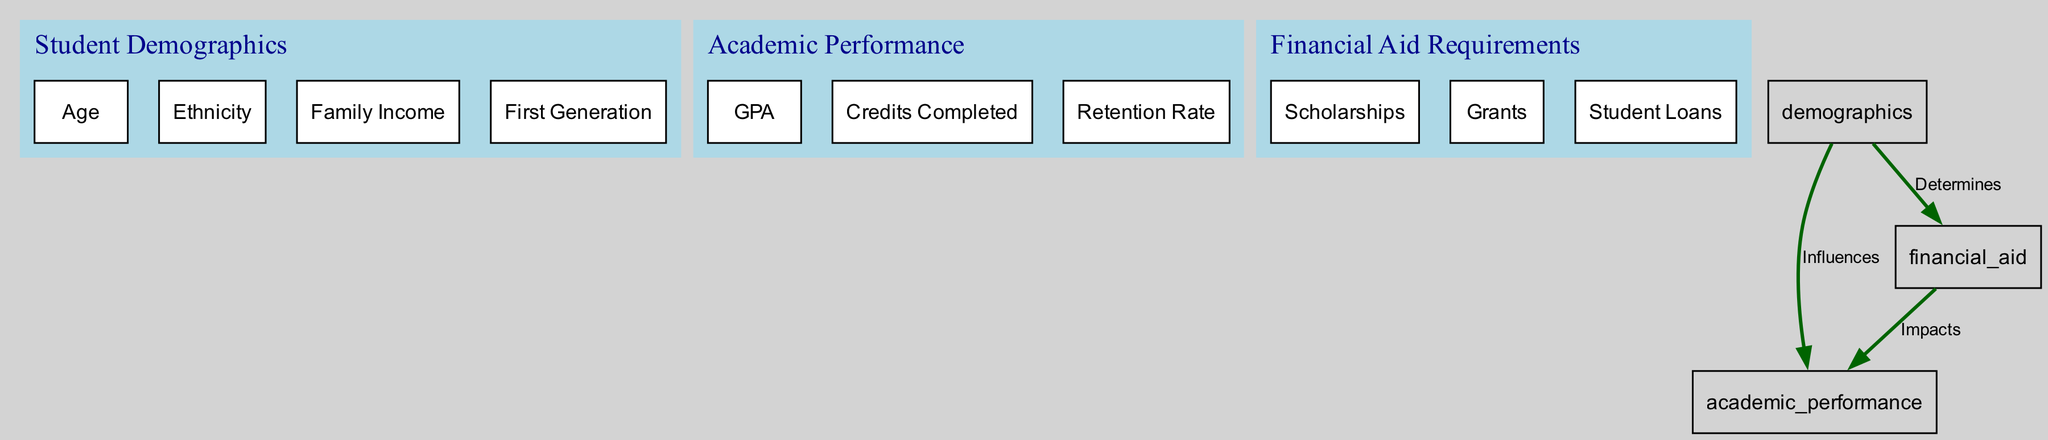What are the three main categories represented in the diagram? The diagram shows three main categories: Student Demographics, Academic Performance, and Financial Aid Requirements, as indicated by the distinct clusters.
Answer: Student Demographics, Academic Performance, Financial Aid Requirements How many children does the Student Demographics node have? The Student Demographics node includes four children: Age, Ethnicity, Family Income, and First Generation, which can be counted in the respective cluster.
Answer: Four What is the relationship between Student Demographics and Academic Performance? The edge between Student Demographics and Academic Performance is labeled "Influences," indicating that demographics have an impact on students' academic performance in the diagram.
Answer: Influences Which financial aid type impacts academic performance? The edge from Financial Aid Requirements to Academic Performance is labeled "Impacts," suggesting that financial aid can affect students' academic performance.
Answer: Impacts What are the elements that determine financial aid requirements? The Financial Aid Requirements node is determined by the Student Demographics, particularly the aspects of family income and first-generation status, as implied by the outgoing edge.
Answer: Family Income, First Generation How many edges are present in the diagram? The diagram features three edges connecting the nodes, specifically describing the relationships between Student Demographics, Academic Performance, and Financial Aid Requirements.
Answer: Three What influence does Family Income have in the diagram? Family Income falls under the influences from Student Demographics to Academic Performance, meaning it impacts academic performance indirectly through demographic variables.
Answer: Influences academic performance What node impacts academic performance directly? Financial Aid Requirements directly impacts Academic Performance in the diagram, as represented by the directed edge connecting these two nodes.
Answer: Financial Aid Requirements 